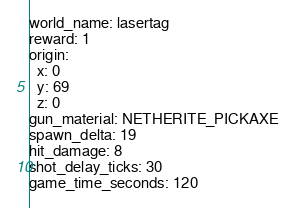<code> <loc_0><loc_0><loc_500><loc_500><_YAML_>world_name: lasertag
reward: 1
origin:
  x: 0
  y: 69
  z: 0
gun_material: NETHERITE_PICKAXE
spawn_delta: 19
hit_damage: 8
shot_delay_ticks: 30
game_time_seconds: 120</code> 